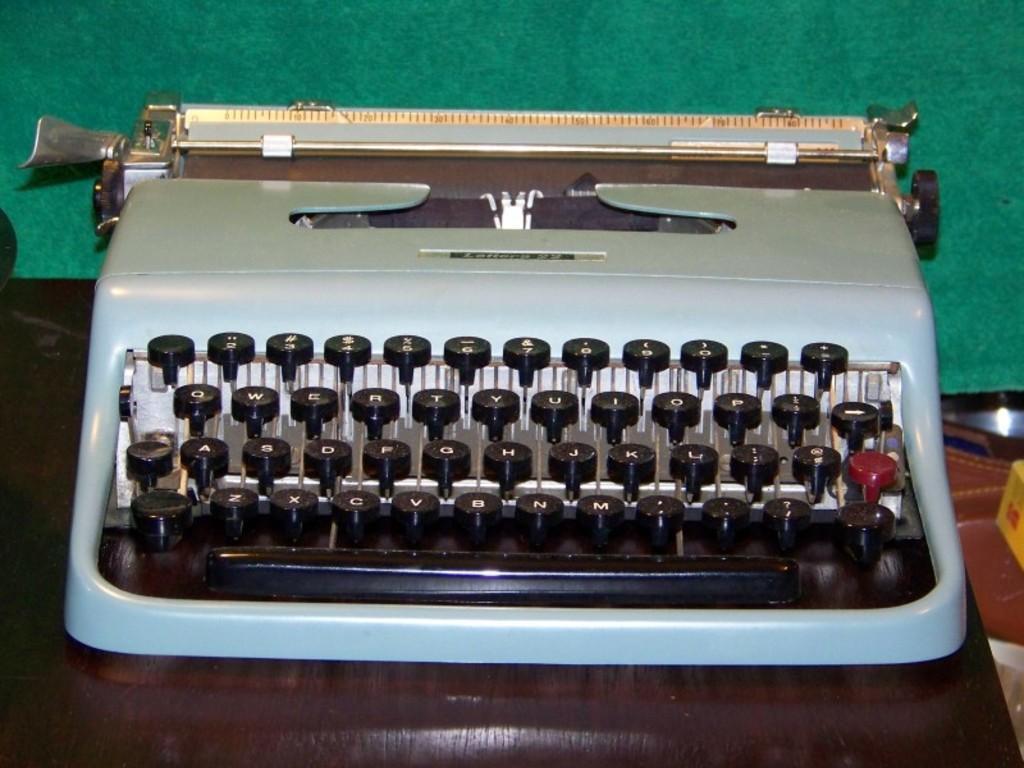Could you give a brief overview of what you see in this image? In this picture I can observe a typewriter. I can observe black color keys. This typewriter is placed on the brown color table. The background is in green color. 